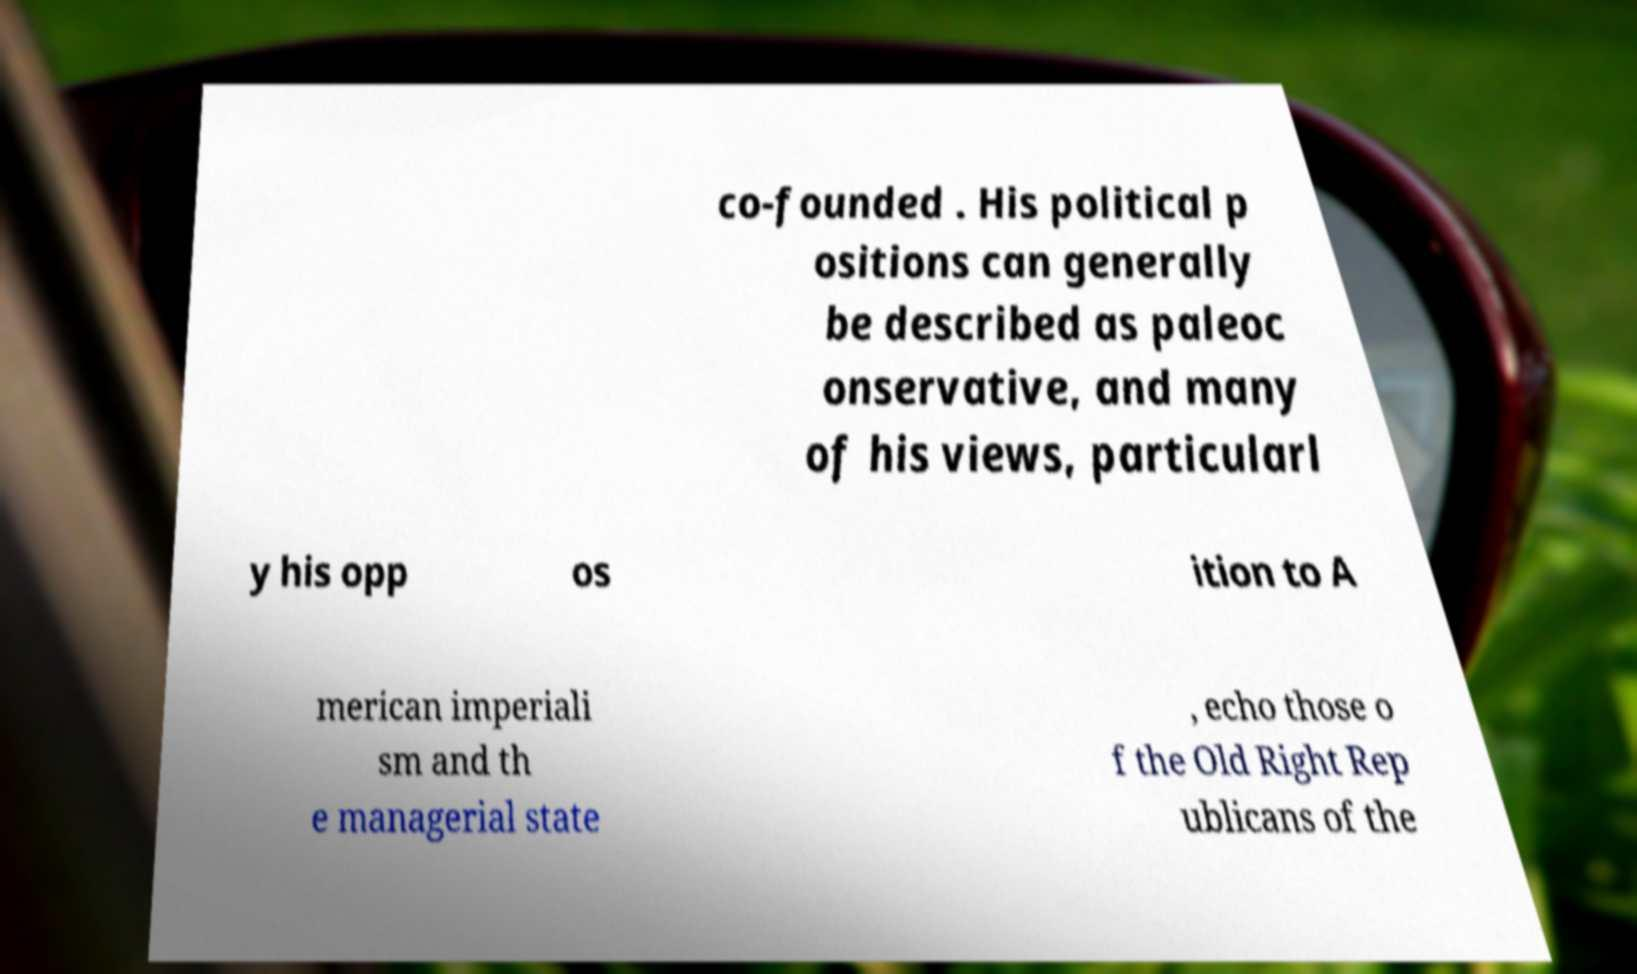Please read and relay the text visible in this image. What does it say? co-founded . His political p ositions can generally be described as paleoc onservative, and many of his views, particularl y his opp os ition to A merican imperiali sm and th e managerial state , echo those o f the Old Right Rep ublicans of the 